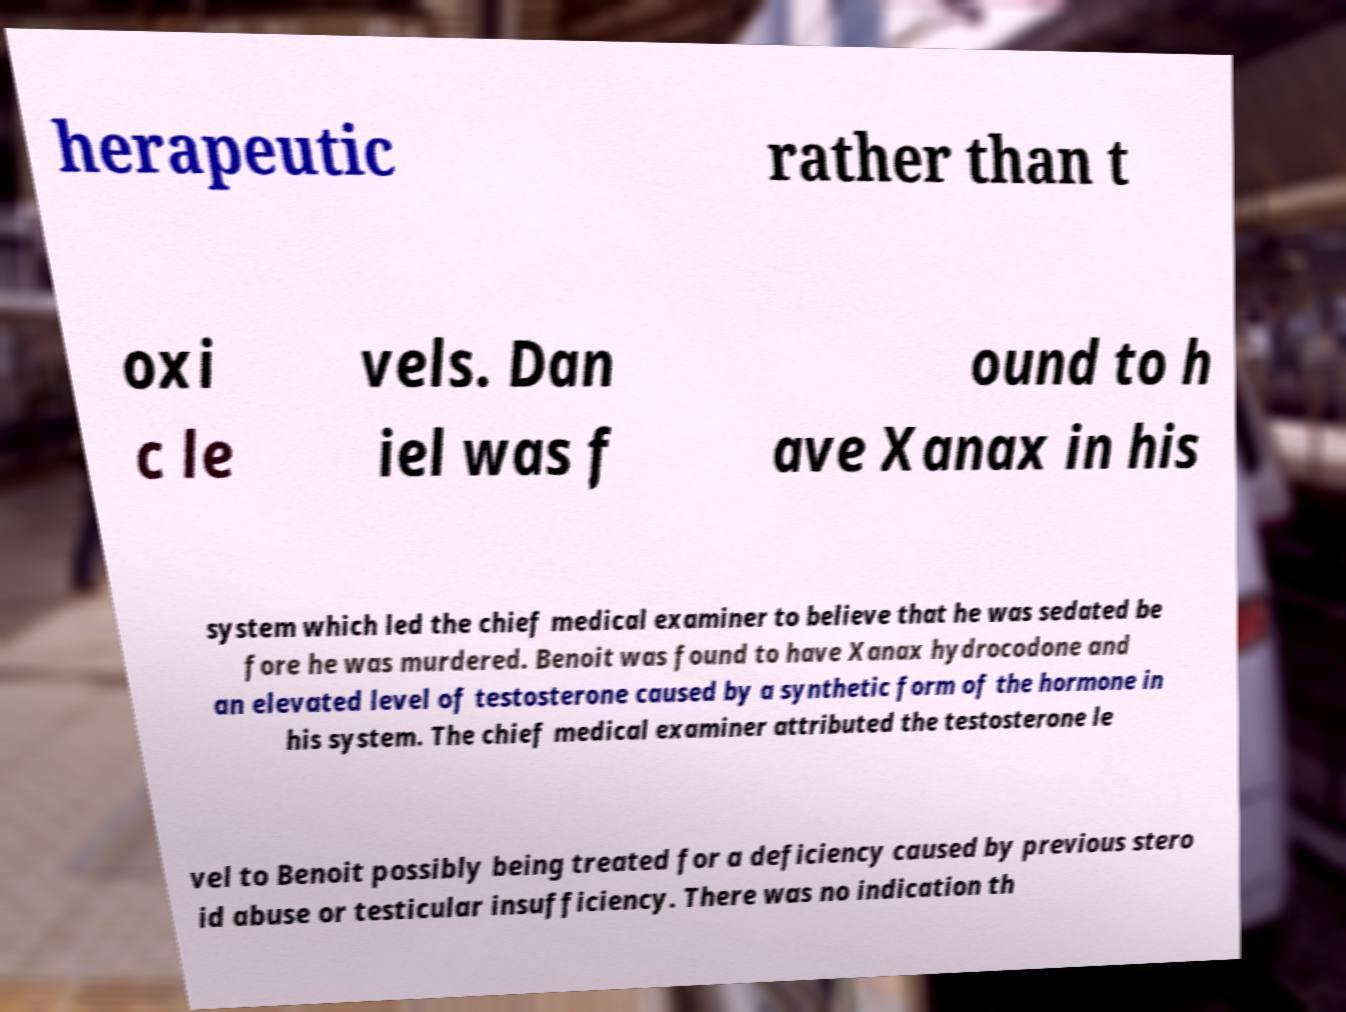Could you assist in decoding the text presented in this image and type it out clearly? herapeutic rather than t oxi c le vels. Dan iel was f ound to h ave Xanax in his system which led the chief medical examiner to believe that he was sedated be fore he was murdered. Benoit was found to have Xanax hydrocodone and an elevated level of testosterone caused by a synthetic form of the hormone in his system. The chief medical examiner attributed the testosterone le vel to Benoit possibly being treated for a deficiency caused by previous stero id abuse or testicular insufficiency. There was no indication th 